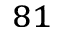<formula> <loc_0><loc_0><loc_500><loc_500>^ { 8 1 }</formula> 